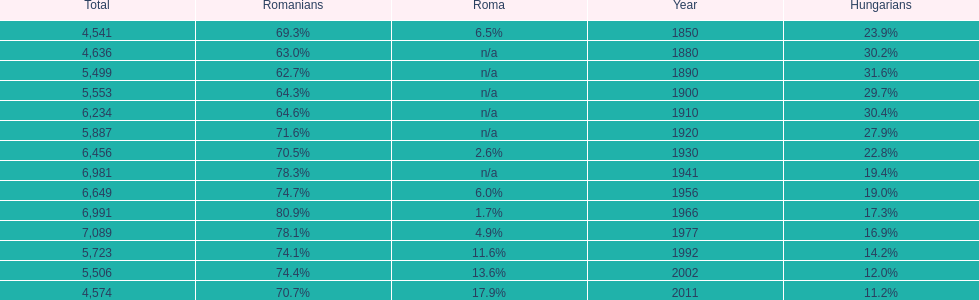What was the count of occurrences when the romanians' population percentage went beyond 70%? 9. 